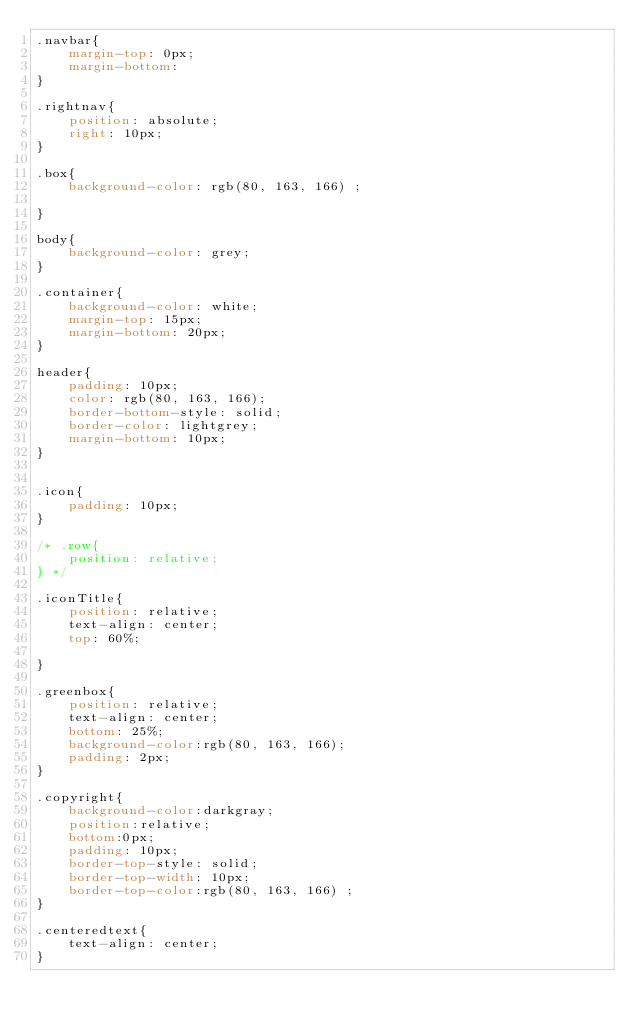Convert code to text. <code><loc_0><loc_0><loc_500><loc_500><_CSS_>.navbar{
    margin-top: 0px;
    margin-bottom:
} 

.rightnav{
    position: absolute;
    right: 10px;
}

.box{
    background-color: rgb(80, 163, 166) ;

}

body{
    background-color: grey;
}

.container{
    background-color: white;
    margin-top: 15px;
    margin-bottom: 20px;
}

header{
    padding: 10px;
    color: rgb(80, 163, 166);
    border-bottom-style: solid;
    border-color: lightgrey;
    margin-bottom: 10px;
}


.icon{
    padding: 10px;
}

/* .row{
    position: relative;
} */

.iconTitle{
    position: relative;
    text-align: center;
    top: 60%;

}

.greenbox{
    position: relative;
    text-align: center;
    bottom: 25%;
    background-color:rgb(80, 163, 166);
    padding: 2px;
}

.copyright{
    background-color:darkgray;
    position:relative;
    bottom:0px;
    padding: 10px;
    border-top-style: solid;
    border-top-width: 10px;
    border-top-color:rgb(80, 163, 166) ;
}

.centeredtext{
    text-align: center;
}
</code> 